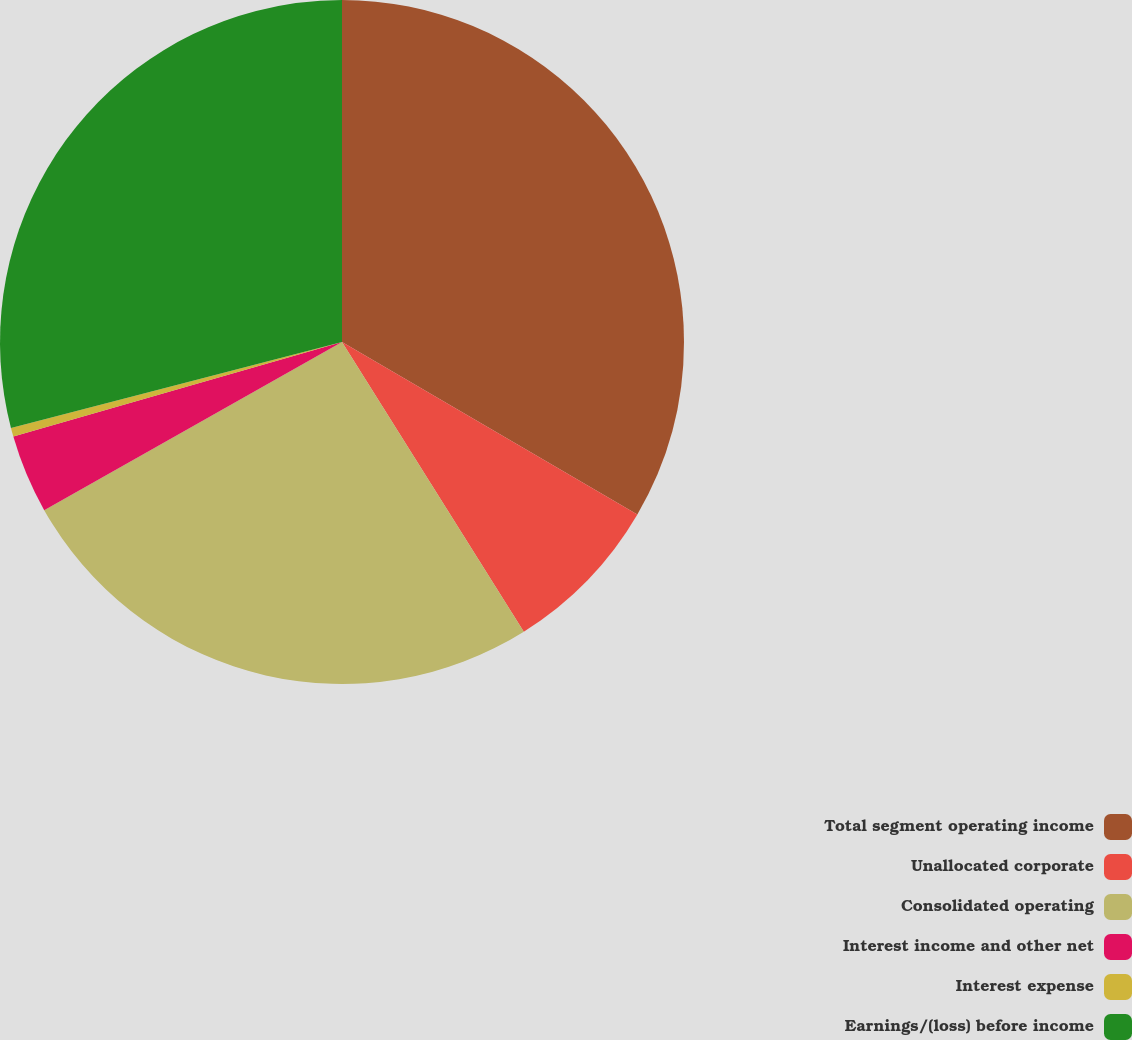Convert chart to OTSL. <chart><loc_0><loc_0><loc_500><loc_500><pie_chart><fcel>Total segment operating income<fcel>Unallocated corporate<fcel>Consolidated operating<fcel>Interest income and other net<fcel>Interest expense<fcel>Earnings/(loss) before income<nl><fcel>33.41%<fcel>7.67%<fcel>25.74%<fcel>3.72%<fcel>0.42%<fcel>29.04%<nl></chart> 